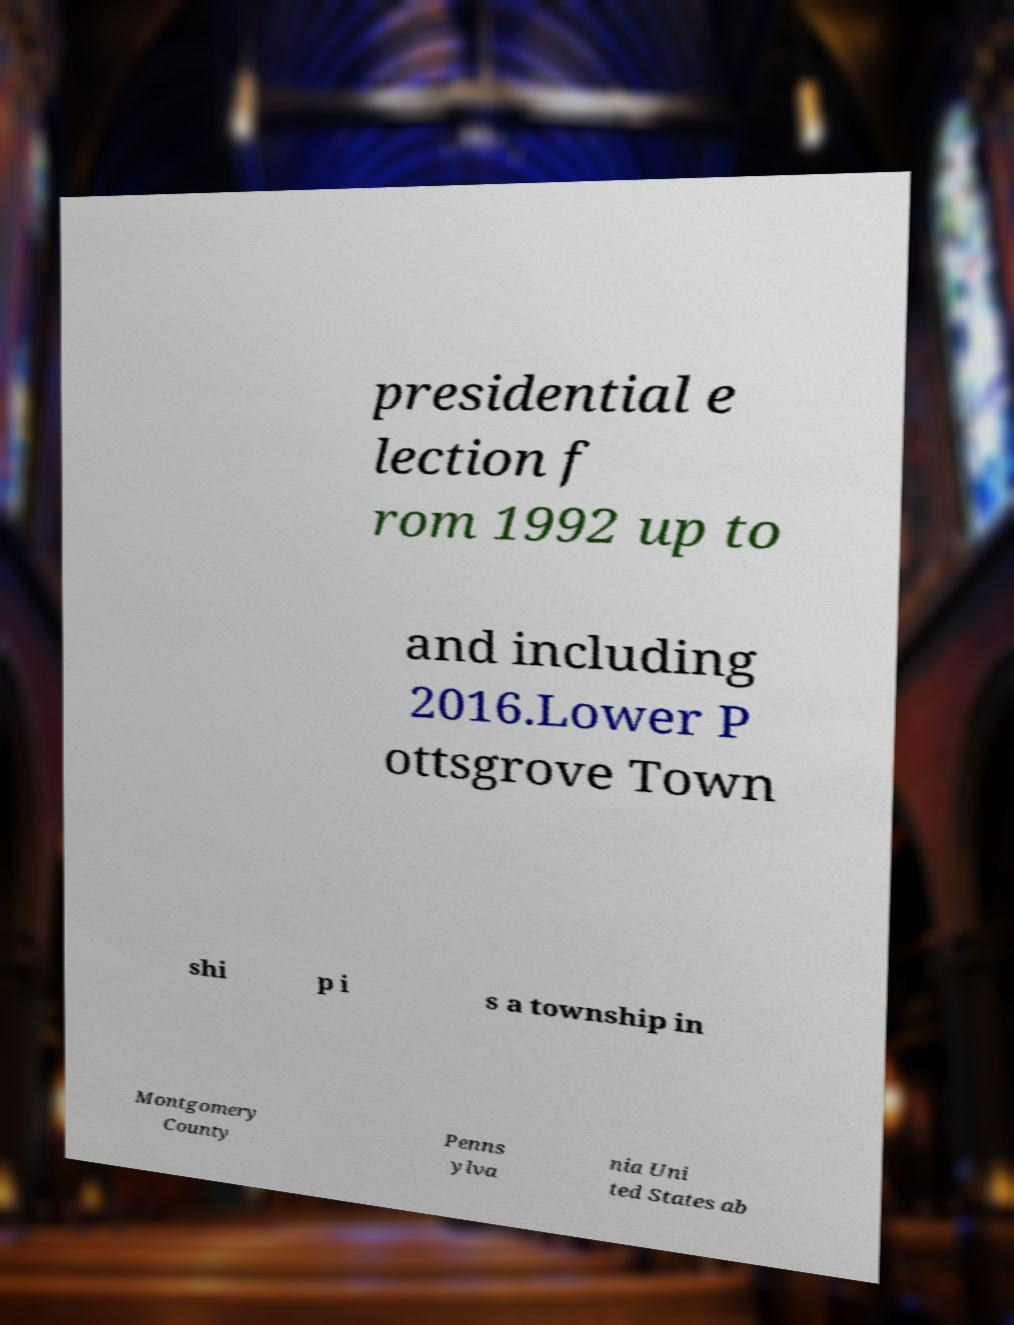Please read and relay the text visible in this image. What does it say? presidential e lection f rom 1992 up to and including 2016.Lower P ottsgrove Town shi p i s a township in Montgomery County Penns ylva nia Uni ted States ab 